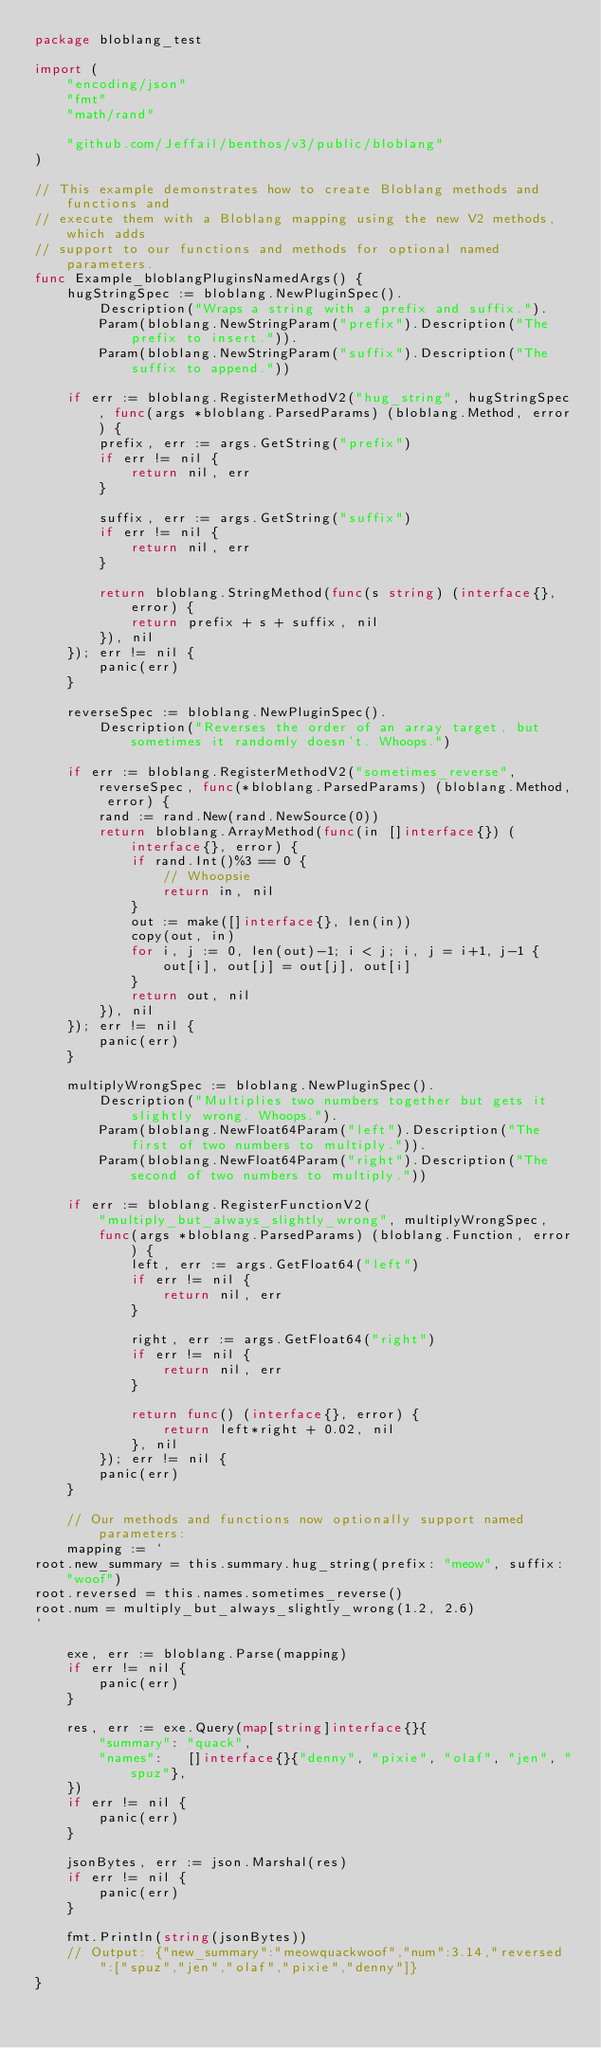<code> <loc_0><loc_0><loc_500><loc_500><_Go_>package bloblang_test

import (
	"encoding/json"
	"fmt"
	"math/rand"

	"github.com/Jeffail/benthos/v3/public/bloblang"
)

// This example demonstrates how to create Bloblang methods and functions and
// execute them with a Bloblang mapping using the new V2 methods, which adds
// support to our functions and methods for optional named parameters.
func Example_bloblangPluginsNamedArgs() {
	hugStringSpec := bloblang.NewPluginSpec().
		Description("Wraps a string with a prefix and suffix.").
		Param(bloblang.NewStringParam("prefix").Description("The prefix to insert.")).
		Param(bloblang.NewStringParam("suffix").Description("The suffix to append."))

	if err := bloblang.RegisterMethodV2("hug_string", hugStringSpec, func(args *bloblang.ParsedParams) (bloblang.Method, error) {
		prefix, err := args.GetString("prefix")
		if err != nil {
			return nil, err
		}

		suffix, err := args.GetString("suffix")
		if err != nil {
			return nil, err
		}

		return bloblang.StringMethod(func(s string) (interface{}, error) {
			return prefix + s + suffix, nil
		}), nil
	}); err != nil {
		panic(err)
	}

	reverseSpec := bloblang.NewPluginSpec().
		Description("Reverses the order of an array target, but sometimes it randomly doesn't. Whoops.")

	if err := bloblang.RegisterMethodV2("sometimes_reverse", reverseSpec, func(*bloblang.ParsedParams) (bloblang.Method, error) {
		rand := rand.New(rand.NewSource(0))
		return bloblang.ArrayMethod(func(in []interface{}) (interface{}, error) {
			if rand.Int()%3 == 0 {
				// Whoopsie
				return in, nil
			}
			out := make([]interface{}, len(in))
			copy(out, in)
			for i, j := 0, len(out)-1; i < j; i, j = i+1, j-1 {
				out[i], out[j] = out[j], out[i]
			}
			return out, nil
		}), nil
	}); err != nil {
		panic(err)
	}

	multiplyWrongSpec := bloblang.NewPluginSpec().
		Description("Multiplies two numbers together but gets it slightly wrong. Whoops.").
		Param(bloblang.NewFloat64Param("left").Description("The first of two numbers to multiply.")).
		Param(bloblang.NewFloat64Param("right").Description("The second of two numbers to multiply."))

	if err := bloblang.RegisterFunctionV2(
		"multiply_but_always_slightly_wrong", multiplyWrongSpec,
		func(args *bloblang.ParsedParams) (bloblang.Function, error) {
			left, err := args.GetFloat64("left")
			if err != nil {
				return nil, err
			}

			right, err := args.GetFloat64("right")
			if err != nil {
				return nil, err
			}

			return func() (interface{}, error) {
				return left*right + 0.02, nil
			}, nil
		}); err != nil {
		panic(err)
	}

	// Our methods and functions now optionally support named parameters:
	mapping := `
root.new_summary = this.summary.hug_string(prefix: "meow", suffix: "woof")
root.reversed = this.names.sometimes_reverse()
root.num = multiply_but_always_slightly_wrong(1.2, 2.6)
`

	exe, err := bloblang.Parse(mapping)
	if err != nil {
		panic(err)
	}

	res, err := exe.Query(map[string]interface{}{
		"summary": "quack",
		"names":   []interface{}{"denny", "pixie", "olaf", "jen", "spuz"},
	})
	if err != nil {
		panic(err)
	}

	jsonBytes, err := json.Marshal(res)
	if err != nil {
		panic(err)
	}

	fmt.Println(string(jsonBytes))
	// Output: {"new_summary":"meowquackwoof","num":3.14,"reversed":["spuz","jen","olaf","pixie","denny"]}
}
</code> 